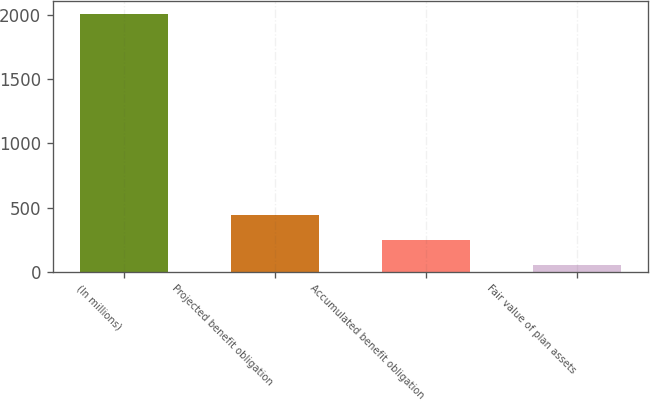Convert chart to OTSL. <chart><loc_0><loc_0><loc_500><loc_500><bar_chart><fcel>(In millions)<fcel>Projected benefit obligation<fcel>Accumulated benefit obligation<fcel>Fair value of plan assets<nl><fcel>2009<fcel>440.2<fcel>244.1<fcel>48<nl></chart> 